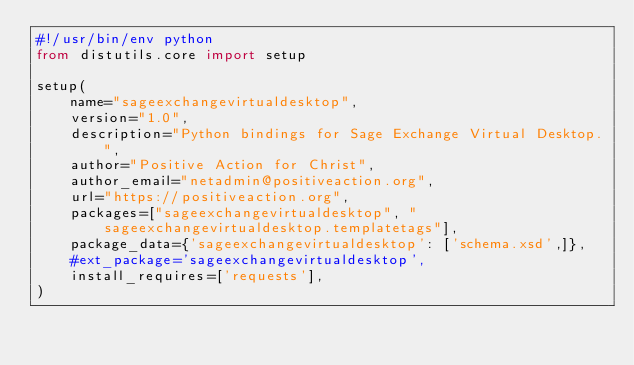Convert code to text. <code><loc_0><loc_0><loc_500><loc_500><_Python_>#!/usr/bin/env python
from distutils.core import setup

setup(
    name="sageexchangevirtualdesktop",
    version="1.0",
    description="Python bindings for Sage Exchange Virtual Desktop.",
    author="Positive Action for Christ",
    author_email="netadmin@positiveaction.org",
    url="https://positiveaction.org",
    packages=["sageexchangevirtualdesktop", "sageexchangevirtualdesktop.templatetags"],
    package_data={'sageexchangevirtualdesktop': ['schema.xsd',]},
    #ext_package='sageexchangevirtualdesktop',
    install_requires=['requests'],
)</code> 